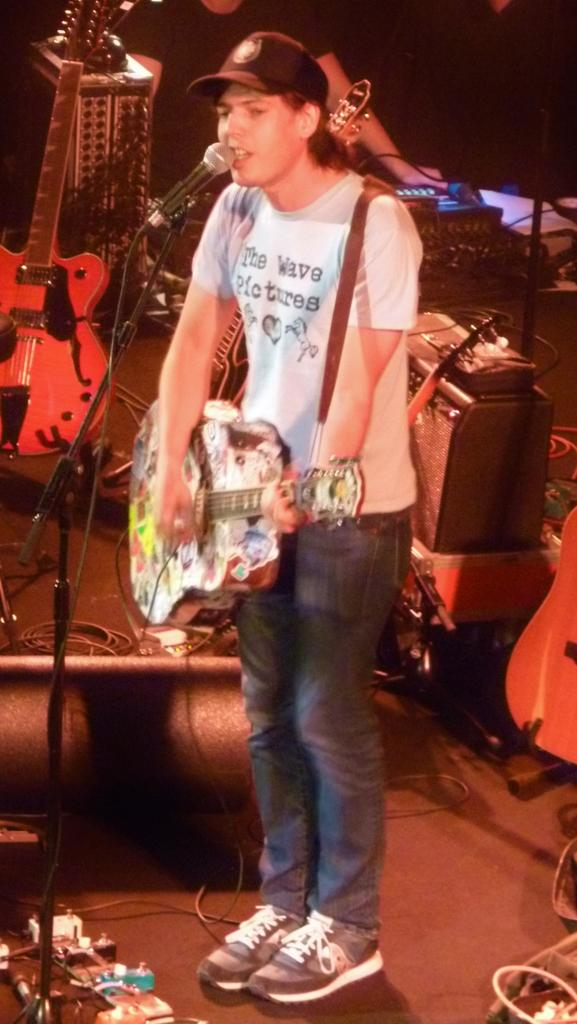Who is the main subject in the image? There is a man in the image. What is the man wearing? The man is wearing a white t-shirt. What is the man holding in the image? The man is holding a guitar. What is the man doing with the guitar? The man is singing a song. What equipment is set up in front of the man? There is a microphone with a stand in front of the man. What can be seen behind the man? There are music systems visible behind the man. What sense does the man lack in the image? There is no indication in the image that the man lacks any sense. What is the relation between the man and the music systems behind him? The image does not provide information about the man's relation to the music systems; it only shows that they are visible behind him. 